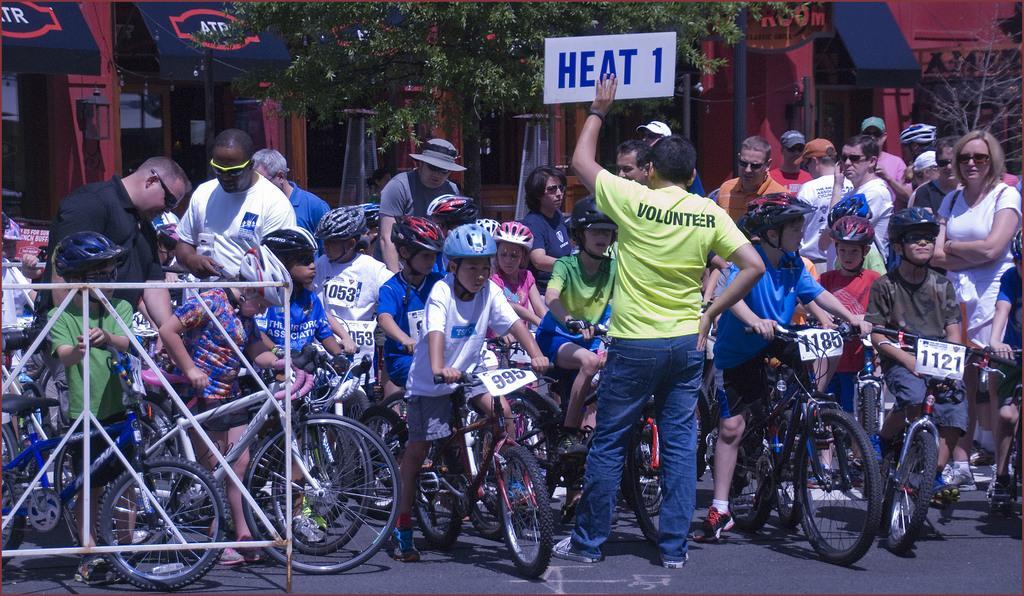Please provide a concise description of this image. In this image we can see children sitting on the bicycles and people are standing on the road. In the background there are buildings, trees and grills. 